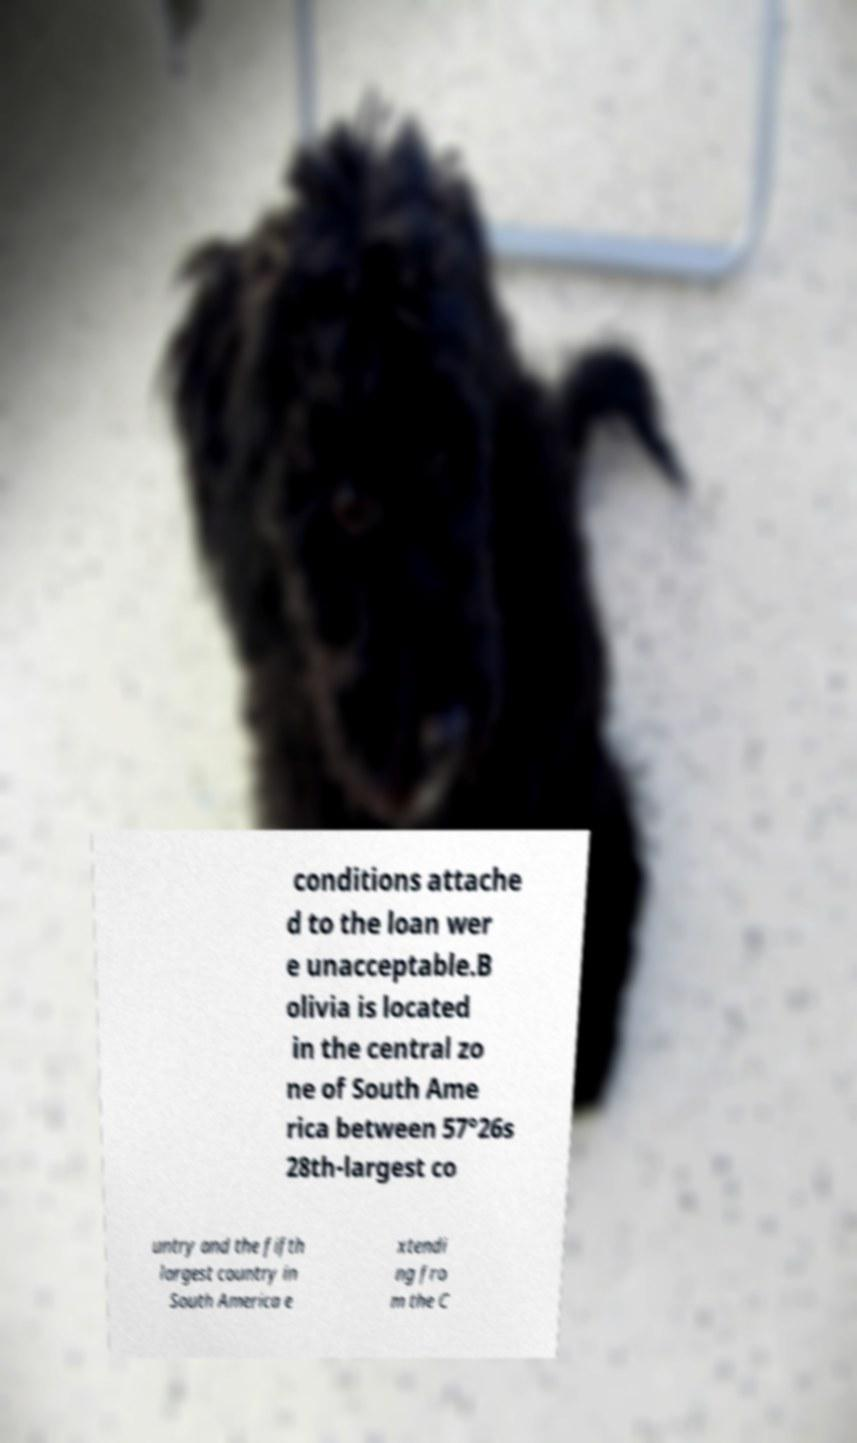Please identify and transcribe the text found in this image. conditions attache d to the loan wer e unacceptable.B olivia is located in the central zo ne of South Ame rica between 57°26s 28th-largest co untry and the fifth largest country in South America e xtendi ng fro m the C 